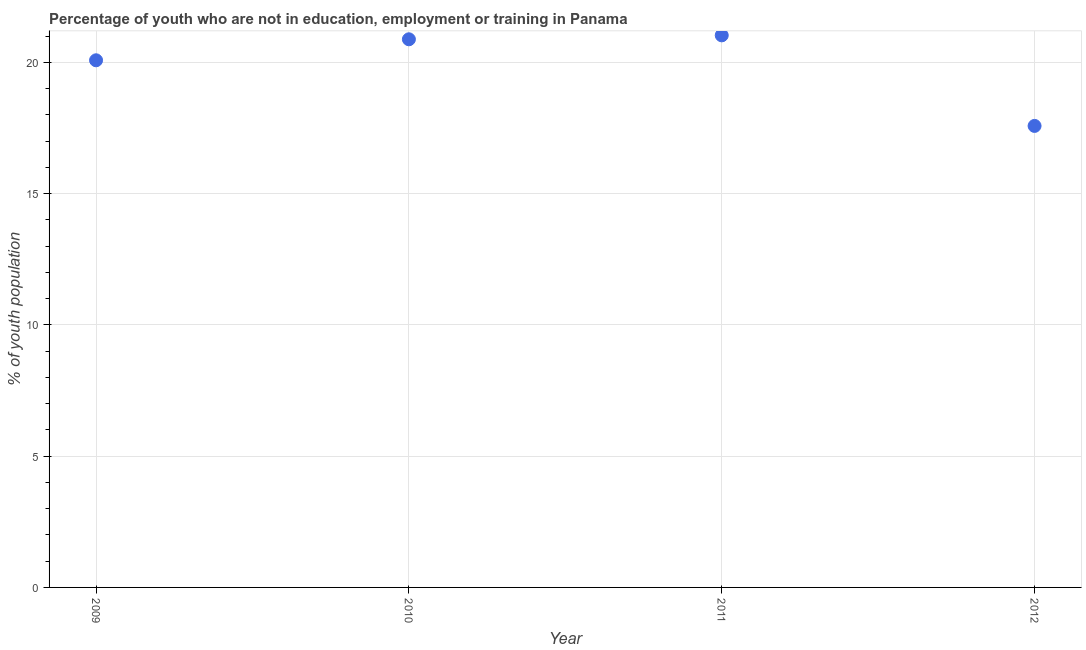What is the unemployed youth population in 2012?
Your response must be concise. 17.58. Across all years, what is the maximum unemployed youth population?
Offer a very short reply. 21.03. Across all years, what is the minimum unemployed youth population?
Offer a terse response. 17.58. What is the sum of the unemployed youth population?
Your answer should be compact. 79.57. What is the difference between the unemployed youth population in 2009 and 2012?
Give a very brief answer. 2.5. What is the average unemployed youth population per year?
Offer a terse response. 19.89. What is the median unemployed youth population?
Offer a terse response. 20.48. Do a majority of the years between 2009 and 2010 (inclusive) have unemployed youth population greater than 15 %?
Your answer should be compact. Yes. What is the ratio of the unemployed youth population in 2011 to that in 2012?
Make the answer very short. 1.2. What is the difference between the highest and the second highest unemployed youth population?
Your answer should be very brief. 0.15. Is the sum of the unemployed youth population in 2009 and 2010 greater than the maximum unemployed youth population across all years?
Your answer should be compact. Yes. What is the difference between the highest and the lowest unemployed youth population?
Your answer should be very brief. 3.45. In how many years, is the unemployed youth population greater than the average unemployed youth population taken over all years?
Offer a terse response. 3. Does the unemployed youth population monotonically increase over the years?
Your answer should be very brief. No. What is the difference between two consecutive major ticks on the Y-axis?
Your answer should be compact. 5. Does the graph contain grids?
Your answer should be compact. Yes. What is the title of the graph?
Keep it short and to the point. Percentage of youth who are not in education, employment or training in Panama. What is the label or title of the X-axis?
Give a very brief answer. Year. What is the label or title of the Y-axis?
Offer a very short reply. % of youth population. What is the % of youth population in 2009?
Offer a very short reply. 20.08. What is the % of youth population in 2010?
Offer a very short reply. 20.88. What is the % of youth population in 2011?
Provide a succinct answer. 21.03. What is the % of youth population in 2012?
Keep it short and to the point. 17.58. What is the difference between the % of youth population in 2009 and 2010?
Your response must be concise. -0.8. What is the difference between the % of youth population in 2009 and 2011?
Make the answer very short. -0.95. What is the difference between the % of youth population in 2009 and 2012?
Your answer should be very brief. 2.5. What is the difference between the % of youth population in 2010 and 2012?
Provide a short and direct response. 3.3. What is the difference between the % of youth population in 2011 and 2012?
Provide a short and direct response. 3.45. What is the ratio of the % of youth population in 2009 to that in 2011?
Your response must be concise. 0.95. What is the ratio of the % of youth population in 2009 to that in 2012?
Offer a very short reply. 1.14. What is the ratio of the % of youth population in 2010 to that in 2011?
Give a very brief answer. 0.99. What is the ratio of the % of youth population in 2010 to that in 2012?
Keep it short and to the point. 1.19. What is the ratio of the % of youth population in 2011 to that in 2012?
Make the answer very short. 1.2. 